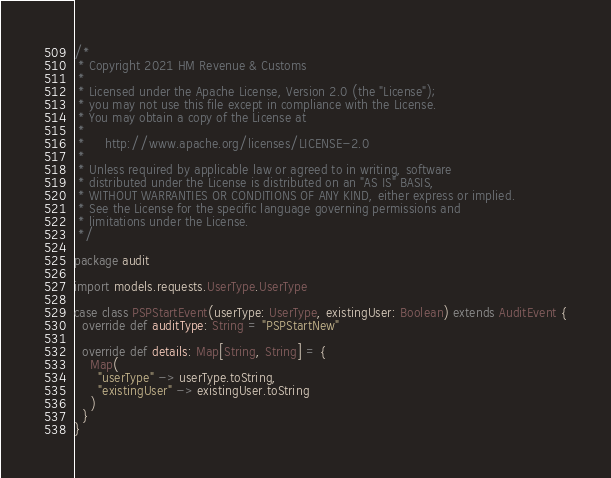Convert code to text. <code><loc_0><loc_0><loc_500><loc_500><_Scala_>/*
 * Copyright 2021 HM Revenue & Customs
 *
 * Licensed under the Apache License, Version 2.0 (the "License");
 * you may not use this file except in compliance with the License.
 * You may obtain a copy of the License at
 *
 *     http://www.apache.org/licenses/LICENSE-2.0
 *
 * Unless required by applicable law or agreed to in writing, software
 * distributed under the License is distributed on an "AS IS" BASIS,
 * WITHOUT WARRANTIES OR CONDITIONS OF ANY KIND, either express or implied.
 * See the License for the specific language governing permissions and
 * limitations under the License.
 */

package audit

import models.requests.UserType.UserType

case class PSPStartEvent(userType: UserType, existingUser: Boolean) extends AuditEvent {
  override def auditType: String = "PSPStartNew"

  override def details: Map[String, String] = {
    Map(
      "userType" -> userType.toString,
      "existingUser" -> existingUser.toString
    )
  }
}
</code> 